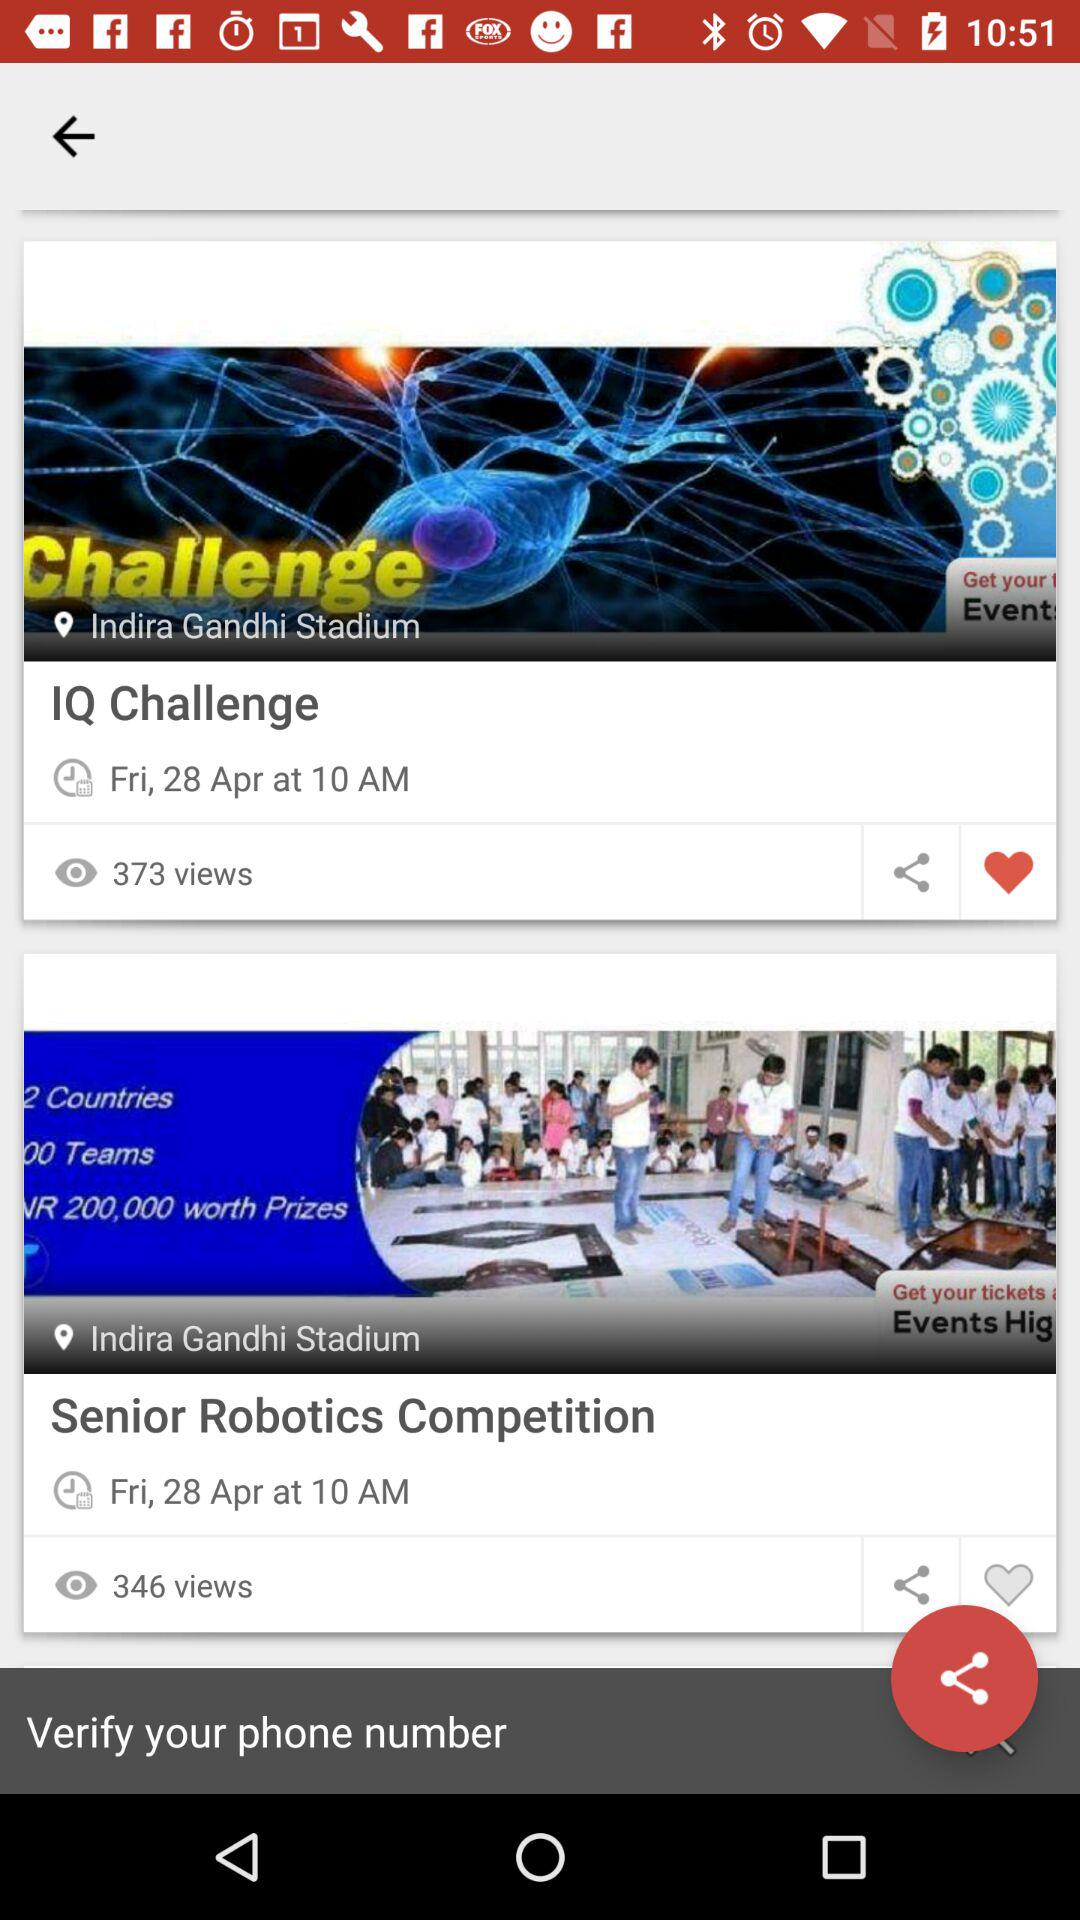How many more views does the Senior Robotics Competition have than the IQ Challenge?
Answer the question using a single word or phrase. 27 